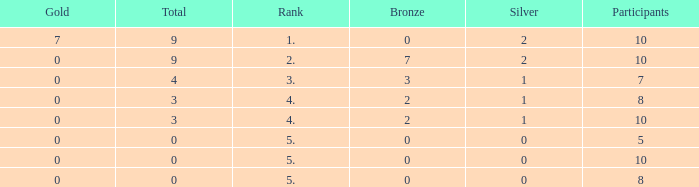What is the overall number of individuals with a silver amount under 0? None. Can you give me this table as a dict? {'header': ['Gold', 'Total', 'Rank', 'Bronze', 'Silver', 'Participants'], 'rows': [['7', '9', '1.', '0', '2', '10'], ['0', '9', '2.', '7', '2', '10'], ['0', '4', '3.', '3', '1', '7'], ['0', '3', '4.', '2', '1', '8'], ['0', '3', '4.', '2', '1', '10'], ['0', '0', '5.', '0', '0', '5'], ['0', '0', '5.', '0', '0', '10'], ['0', '0', '5.', '0', '0', '8']]} 